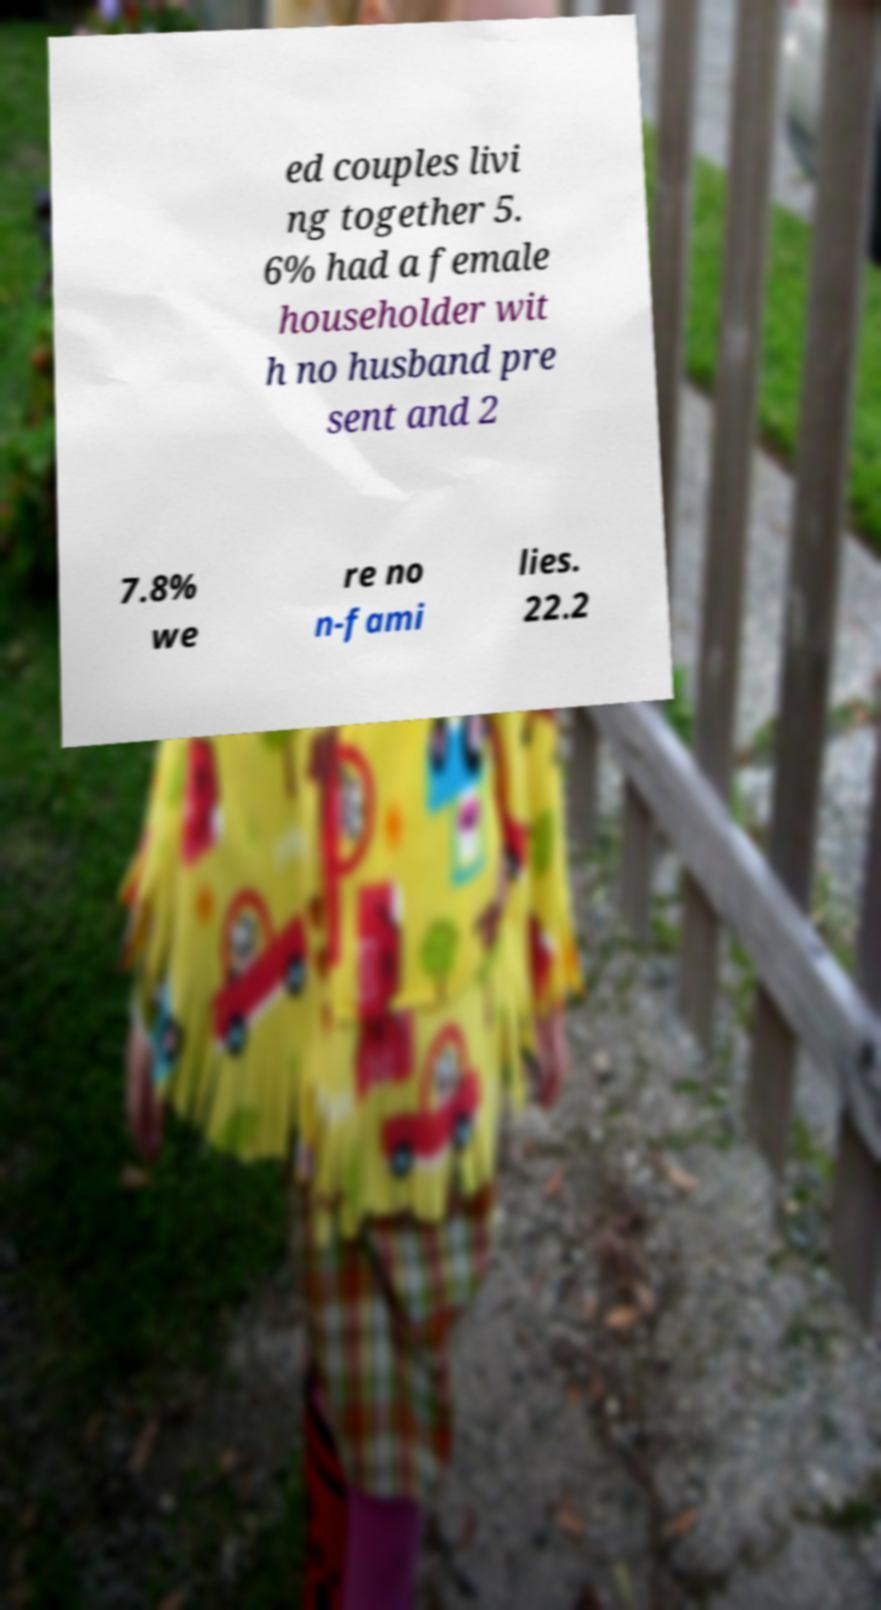What messages or text are displayed in this image? I need them in a readable, typed format. ed couples livi ng together 5. 6% had a female householder wit h no husband pre sent and 2 7.8% we re no n-fami lies. 22.2 